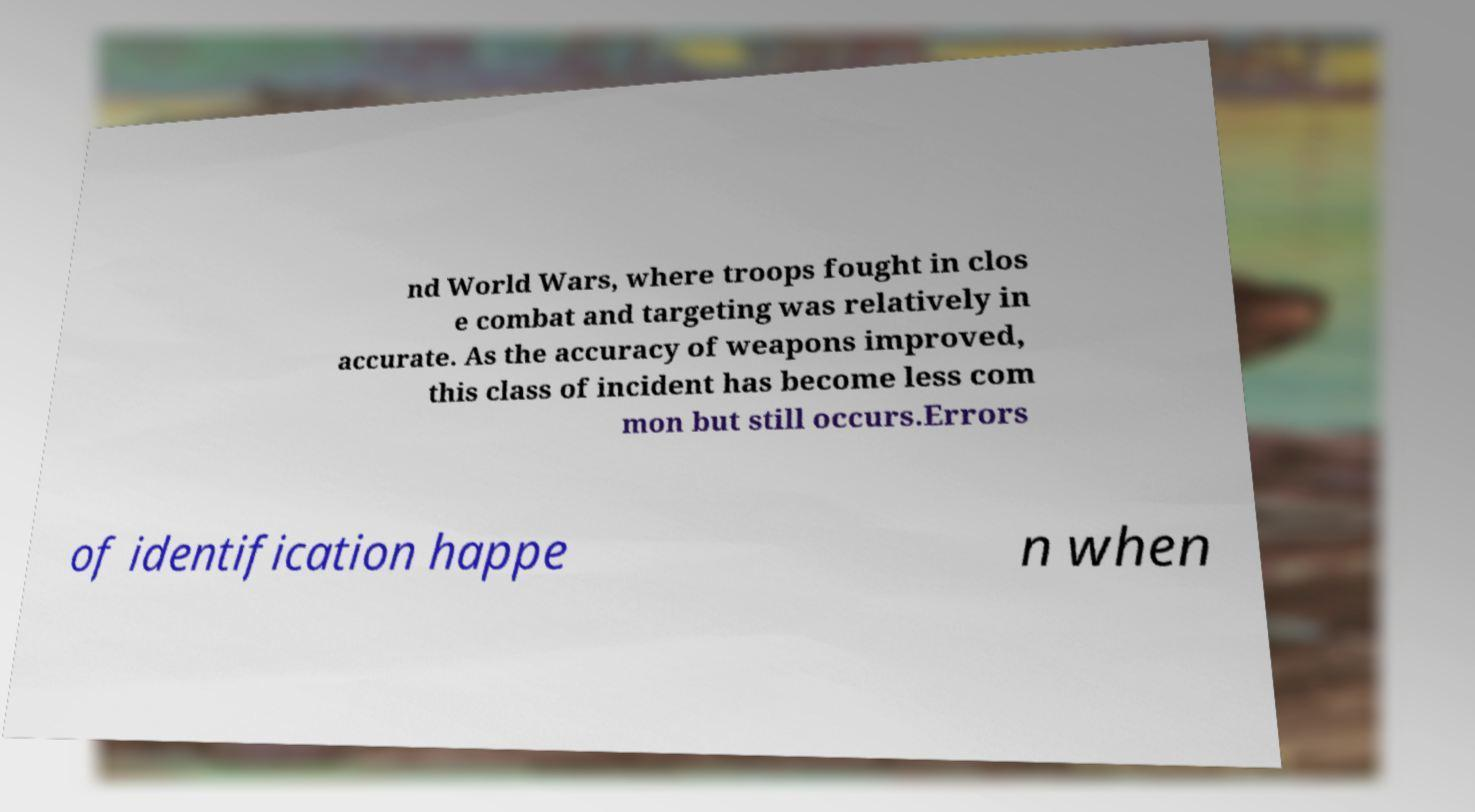For documentation purposes, I need the text within this image transcribed. Could you provide that? nd World Wars, where troops fought in clos e combat and targeting was relatively in accurate. As the accuracy of weapons improved, this class of incident has become less com mon but still occurs.Errors of identification happe n when 